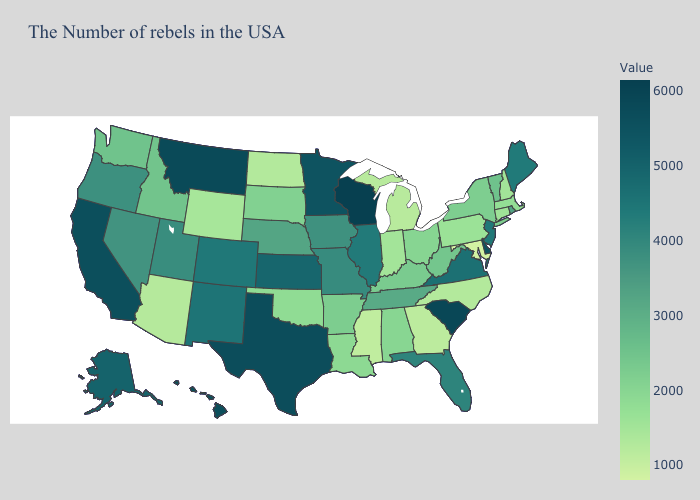Among the states that border Oklahoma , does Kansas have the highest value?
Concise answer only. No. Among the states that border New Jersey , which have the highest value?
Write a very short answer. Delaware. Among the states that border Iowa , which have the lowest value?
Keep it brief. South Dakota. Does Illinois have the lowest value in the MidWest?
Answer briefly. No. Does Idaho have a higher value than Mississippi?
Answer briefly. Yes. Among the states that border Montana , which have the lowest value?
Be succinct. North Dakota. 